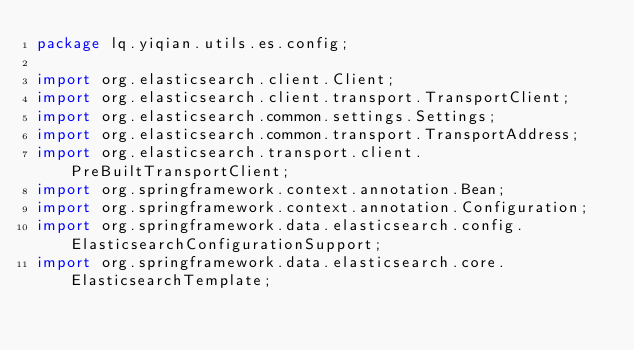Convert code to text. <code><loc_0><loc_0><loc_500><loc_500><_Java_>package lq.yiqian.utils.es.config;

import org.elasticsearch.client.Client;
import org.elasticsearch.client.transport.TransportClient;
import org.elasticsearch.common.settings.Settings;
import org.elasticsearch.common.transport.TransportAddress;
import org.elasticsearch.transport.client.PreBuiltTransportClient;
import org.springframework.context.annotation.Bean;
import org.springframework.context.annotation.Configuration;
import org.springframework.data.elasticsearch.config.ElasticsearchConfigurationSupport;
import org.springframework.data.elasticsearch.core.ElasticsearchTemplate;</code> 